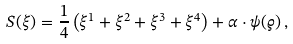Convert formula to latex. <formula><loc_0><loc_0><loc_500><loc_500>S ( \xi ) = \frac { 1 } { 4 } \left ( \xi ^ { 1 } + \xi ^ { 2 } + \xi ^ { 3 } + \xi ^ { 4 } \right ) + \alpha \cdot \psi ( \varrho ) \, ,</formula> 